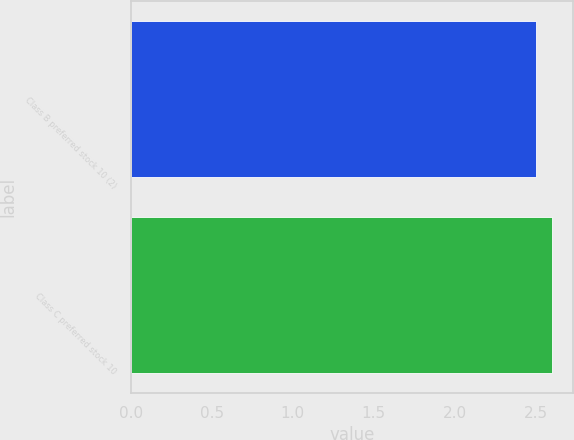Convert chart. <chart><loc_0><loc_0><loc_500><loc_500><bar_chart><fcel>Class B preferred stock 10 (2)<fcel>Class C preferred stock 10<nl><fcel>2.5<fcel>2.6<nl></chart> 